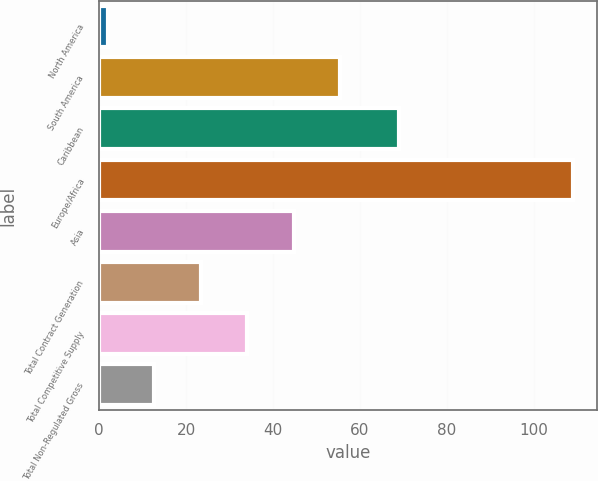Convert chart to OTSL. <chart><loc_0><loc_0><loc_500><loc_500><bar_chart><fcel>North America<fcel>South America<fcel>Caribbean<fcel>Europe/Africa<fcel>Asia<fcel>Total Contract Generation<fcel>Total Competitive Supply<fcel>Total Non-Regulated Gross<nl><fcel>2<fcel>55.5<fcel>69<fcel>109<fcel>44.8<fcel>23.4<fcel>34.1<fcel>12.7<nl></chart> 